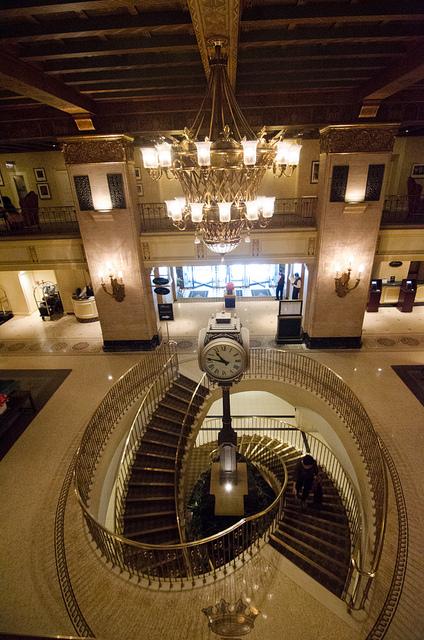Is this a spiral staircase?
Write a very short answer. Yes. Are the lights on or off?
Give a very brief answer. On. What time is it?
Concise answer only. 10:48. 